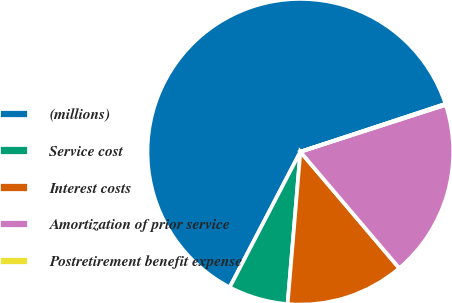Convert chart to OTSL. <chart><loc_0><loc_0><loc_500><loc_500><pie_chart><fcel>(millions)<fcel>Service cost<fcel>Interest costs<fcel>Amortization of prior service<fcel>Postretirement benefit expense<nl><fcel>62.28%<fcel>6.32%<fcel>12.54%<fcel>18.76%<fcel>0.11%<nl></chart> 